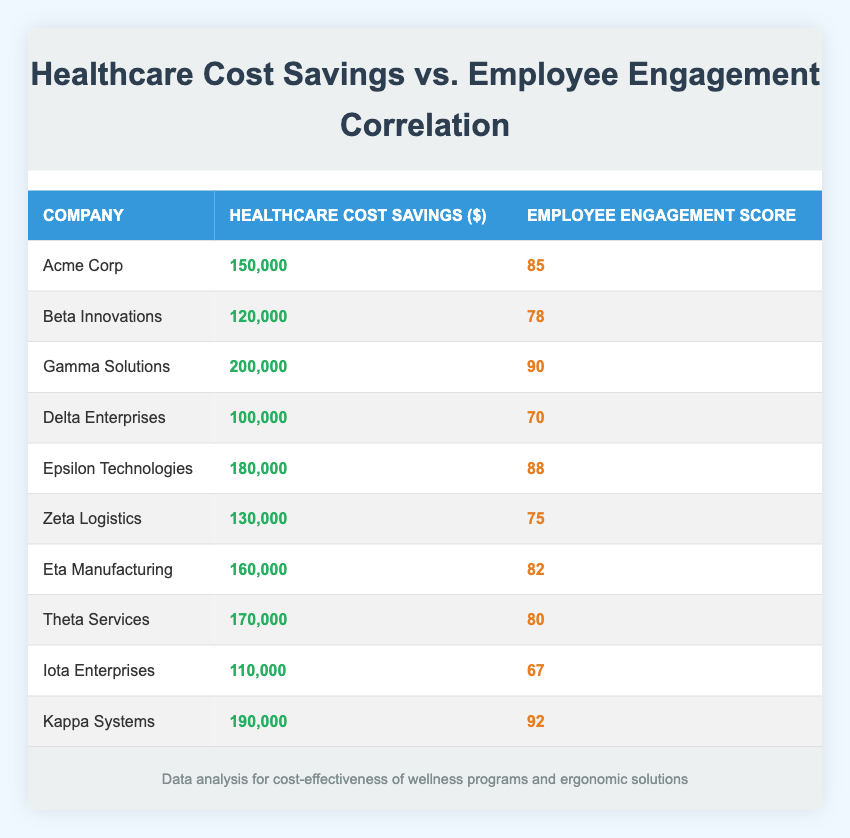What is the healthcare cost savings for Gamma Solutions? The table lists Gamma Solutions with a healthcare cost savings of 200,000.
Answer: 200000 Which company has the highest employee engagement score? The table shows Kappa Systems with an employee engagement score of 92, which is the highest among the companies listed.
Answer: Kappa Systems What is the average healthcare cost savings for all companies listed? To find the average, we first sum the healthcare cost savings: 150000 + 120000 + 200000 + 100000 + 180000 + 130000 + 160000 + 170000 + 110000 + 190000 = 1360000. There are 10 data points, so the average is 1360000 / 10 = 136000.
Answer: 136000 Is the employee engagement score of Epsilon Technologies greater than 80? Epsilon Technologies has an employee engagement score of 88, which is indeed greater than 80.
Answer: Yes What is the difference in healthcare cost savings between the company with the highest and lowest savings? Kappa Systems has the highest savings at 190,000, and Delta Enterprises has the lowest at 100,000. The difference is calculated as 190000 - 100000 = 90000.
Answer: 90000 How many companies have healthcare cost savings over 150,000? The companies with healthcare cost savings over 150,000 are Acme Corp, Gamma Solutions, Epsilon Technologies, Eta Manufacturing, Theta Services, and Kappa Systems. In total, there are 6 such companies.
Answer: 6 Which company is associated with an employee engagement score of 67? The table identifies Iota Enterprises as the company with an employee engagement score of 67.
Answer: Iota Enterprises If we consider only companies with savings over 150,000, what is the average employee engagement score of these companies? The companies with savings over 150,000 are Acme Corp, Gamma Solutions, Epsilon Technologies, Eta Manufacturing, Theta Services, and Kappa Systems. Their engagement scores are 85, 90, 88, 82, 80, and 92 respectively. The average is calculated as (85 + 90 + 88 + 82 + 80 + 92) / 6 = 86.
Answer: 86 What percentage of companies have employee engagement scores below 75? The companies with scores below 75 are Delta Enterprises and Iota Enterprises, totaling 2. There are 10 companies in total, so the percentage is (2 / 10) * 100 = 20%.
Answer: 20% 